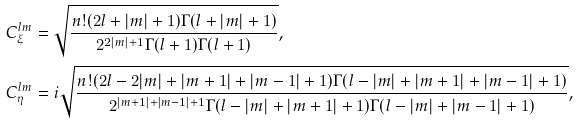Convert formula to latex. <formula><loc_0><loc_0><loc_500><loc_500>C _ { \xi } ^ { l m } & = \sqrt { \frac { n ! ( 2 l + | m | + 1 ) \Gamma ( l + | m | + 1 ) } { 2 ^ { 2 | m | + 1 } \Gamma ( l + 1 ) \Gamma ( l + 1 ) } } , \\ C _ { \eta } ^ { l m } & = i \sqrt { \frac { n ! ( 2 l - 2 | m | + | m + 1 | + | m - 1 | + 1 ) \Gamma ( l - | m | + | m + 1 | + | m - 1 | + 1 ) } { 2 ^ { | m + 1 | + | m - 1 | + 1 } \Gamma ( l - | m | + | m + 1 | + 1 ) \Gamma ( l - | m | + | m - 1 | + 1 ) } } , \\</formula> 